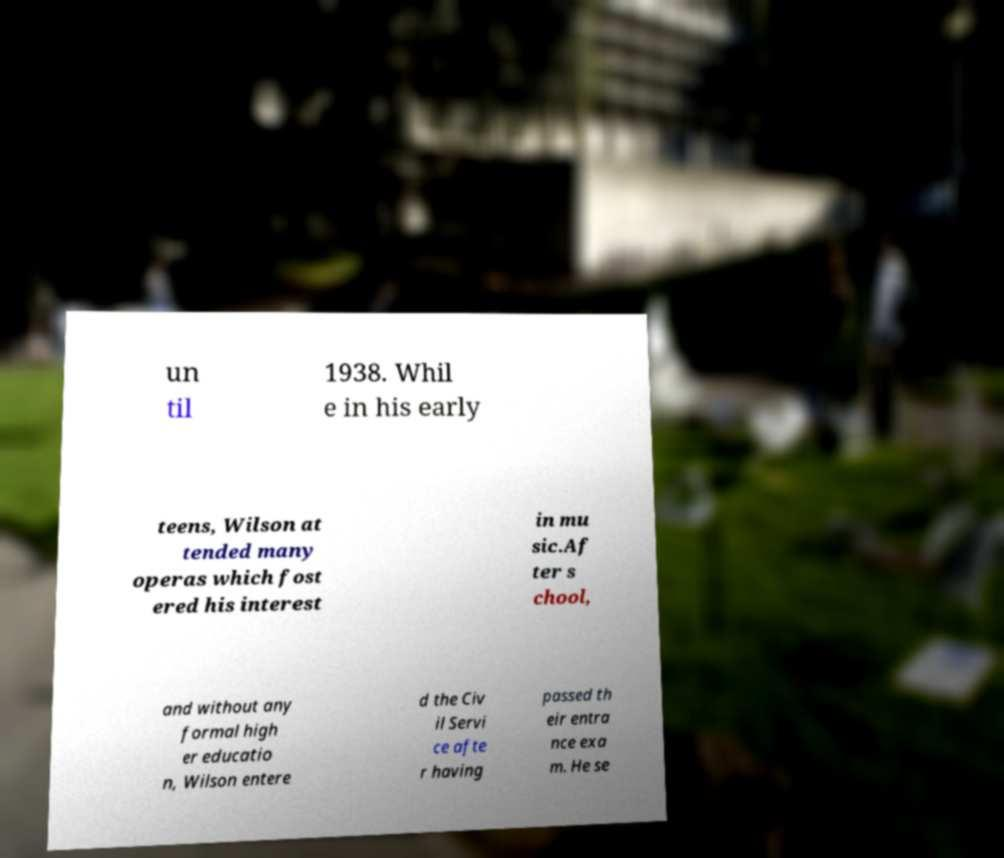Please identify and transcribe the text found in this image. un til 1938. Whil e in his early teens, Wilson at tended many operas which fost ered his interest in mu sic.Af ter s chool, and without any formal high er educatio n, Wilson entere d the Civ il Servi ce afte r having passed th eir entra nce exa m. He se 